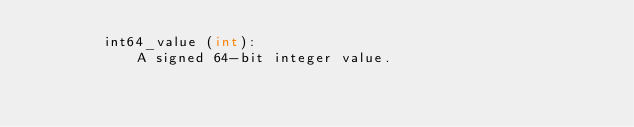<code> <loc_0><loc_0><loc_500><loc_500><_Python_>        int64_value (int):
            A signed 64-bit integer value.
</code> 